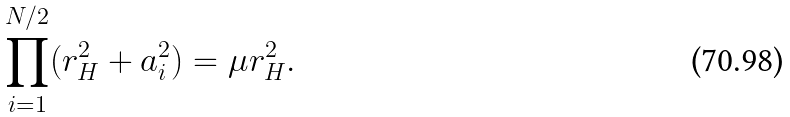<formula> <loc_0><loc_0><loc_500><loc_500>\prod _ { i = 1 } ^ { N / 2 } ( r _ { H } ^ { 2 } + a _ { i } ^ { 2 } ) = \mu r _ { H } ^ { 2 } .</formula> 